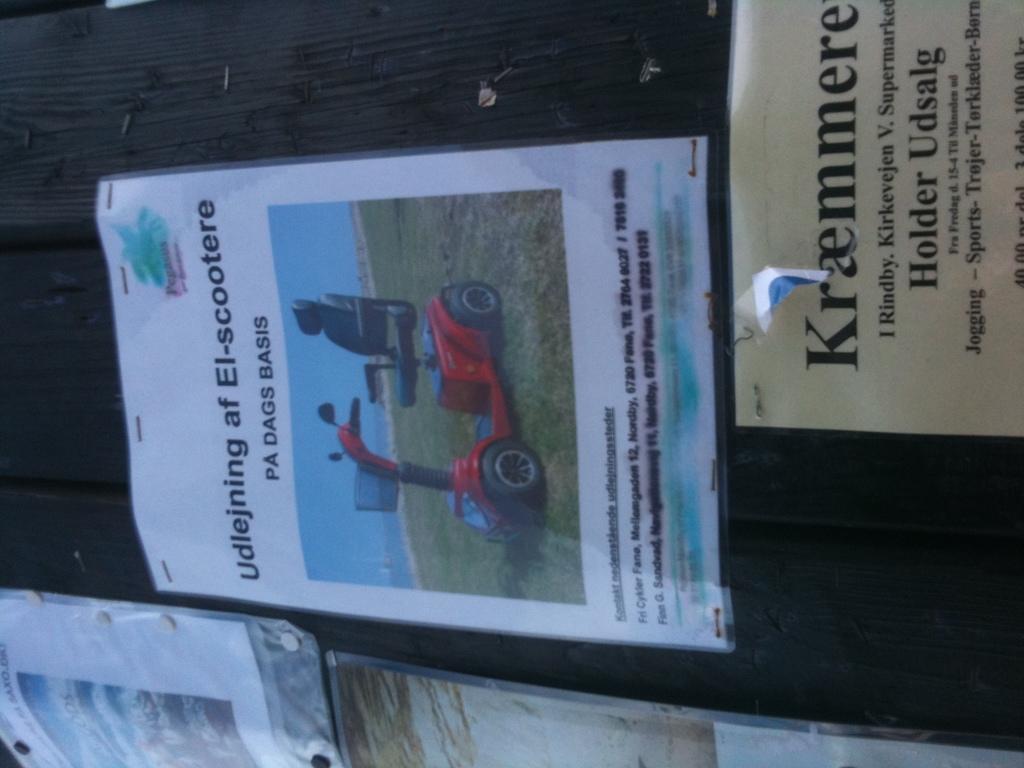Could you give a brief overview of what you see in this image? On a notice board,there are different posters are pinned to it. 